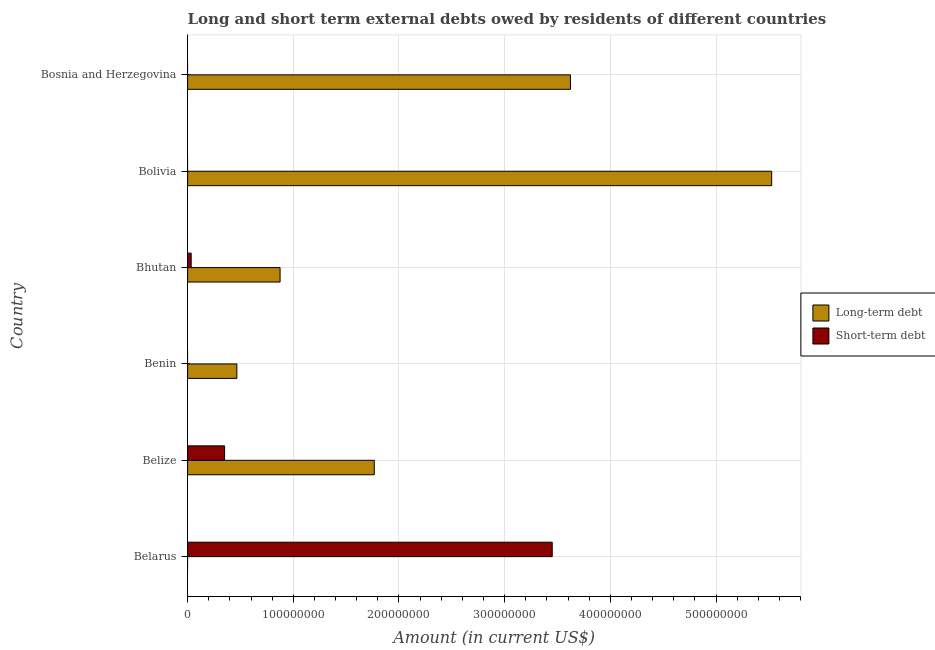How many different coloured bars are there?
Your response must be concise. 2. Are the number of bars per tick equal to the number of legend labels?
Make the answer very short. No. Are the number of bars on each tick of the Y-axis equal?
Make the answer very short. No. How many bars are there on the 3rd tick from the top?
Your answer should be very brief. 2. What is the label of the 4th group of bars from the top?
Offer a very short reply. Benin. In how many cases, is the number of bars for a given country not equal to the number of legend labels?
Offer a terse response. 4. What is the long-term debts owed by residents in Bhutan?
Keep it short and to the point. 8.75e+07. Across all countries, what is the maximum long-term debts owed by residents?
Provide a succinct answer. 5.53e+08. Across all countries, what is the minimum long-term debts owed by residents?
Provide a short and direct response. 0. What is the total short-term debts owed by residents in the graph?
Make the answer very short. 3.83e+08. What is the difference between the long-term debts owed by residents in Bolivia and that in Bosnia and Herzegovina?
Your answer should be compact. 1.90e+08. What is the difference between the short-term debts owed by residents in Bhutan and the long-term debts owed by residents in Benin?
Your answer should be very brief. -4.33e+07. What is the average short-term debts owed by residents per country?
Keep it short and to the point. 6.39e+07. What is the difference between the short-term debts owed by residents and long-term debts owed by residents in Belize?
Your response must be concise. -1.42e+08. What is the ratio of the long-term debts owed by residents in Benin to that in Bhutan?
Offer a terse response. 0.53. What is the difference between the highest and the second highest long-term debts owed by residents?
Provide a short and direct response. 1.90e+08. What is the difference between the highest and the lowest short-term debts owed by residents?
Make the answer very short. 3.45e+08. How many bars are there?
Provide a succinct answer. 8. Are all the bars in the graph horizontal?
Offer a very short reply. Yes. Does the graph contain any zero values?
Ensure brevity in your answer.  Yes. Does the graph contain grids?
Keep it short and to the point. Yes. Where does the legend appear in the graph?
Give a very brief answer. Center right. What is the title of the graph?
Provide a succinct answer. Long and short term external debts owed by residents of different countries. Does "Investments" appear as one of the legend labels in the graph?
Your answer should be very brief. No. What is the label or title of the X-axis?
Your answer should be very brief. Amount (in current US$). What is the Amount (in current US$) in Short-term debt in Belarus?
Offer a very short reply. 3.45e+08. What is the Amount (in current US$) of Long-term debt in Belize?
Ensure brevity in your answer.  1.77e+08. What is the Amount (in current US$) of Short-term debt in Belize?
Your answer should be compact. 3.50e+07. What is the Amount (in current US$) of Long-term debt in Benin?
Your answer should be compact. 4.66e+07. What is the Amount (in current US$) of Long-term debt in Bhutan?
Your response must be concise. 8.75e+07. What is the Amount (in current US$) in Short-term debt in Bhutan?
Provide a succinct answer. 3.38e+06. What is the Amount (in current US$) in Long-term debt in Bolivia?
Your response must be concise. 5.53e+08. What is the Amount (in current US$) of Long-term debt in Bosnia and Herzegovina?
Keep it short and to the point. 3.62e+08. Across all countries, what is the maximum Amount (in current US$) in Long-term debt?
Offer a terse response. 5.53e+08. Across all countries, what is the maximum Amount (in current US$) of Short-term debt?
Make the answer very short. 3.45e+08. Across all countries, what is the minimum Amount (in current US$) of Long-term debt?
Your answer should be very brief. 0. What is the total Amount (in current US$) in Long-term debt in the graph?
Make the answer very short. 1.23e+09. What is the total Amount (in current US$) of Short-term debt in the graph?
Keep it short and to the point. 3.83e+08. What is the difference between the Amount (in current US$) of Short-term debt in Belarus and that in Belize?
Offer a very short reply. 3.10e+08. What is the difference between the Amount (in current US$) in Short-term debt in Belarus and that in Bhutan?
Provide a short and direct response. 3.42e+08. What is the difference between the Amount (in current US$) in Long-term debt in Belize and that in Benin?
Keep it short and to the point. 1.30e+08. What is the difference between the Amount (in current US$) in Long-term debt in Belize and that in Bhutan?
Offer a terse response. 8.91e+07. What is the difference between the Amount (in current US$) of Short-term debt in Belize and that in Bhutan?
Provide a short and direct response. 3.16e+07. What is the difference between the Amount (in current US$) in Long-term debt in Belize and that in Bolivia?
Your answer should be compact. -3.76e+08. What is the difference between the Amount (in current US$) in Long-term debt in Belize and that in Bosnia and Herzegovina?
Provide a succinct answer. -1.86e+08. What is the difference between the Amount (in current US$) of Long-term debt in Benin and that in Bhutan?
Offer a terse response. -4.09e+07. What is the difference between the Amount (in current US$) in Long-term debt in Benin and that in Bolivia?
Your answer should be compact. -5.06e+08. What is the difference between the Amount (in current US$) in Long-term debt in Benin and that in Bosnia and Herzegovina?
Provide a succinct answer. -3.16e+08. What is the difference between the Amount (in current US$) of Long-term debt in Bhutan and that in Bolivia?
Make the answer very short. -4.65e+08. What is the difference between the Amount (in current US$) in Long-term debt in Bhutan and that in Bosnia and Herzegovina?
Your response must be concise. -2.75e+08. What is the difference between the Amount (in current US$) of Long-term debt in Bolivia and that in Bosnia and Herzegovina?
Your answer should be very brief. 1.90e+08. What is the difference between the Amount (in current US$) in Long-term debt in Belize and the Amount (in current US$) in Short-term debt in Bhutan?
Offer a very short reply. 1.73e+08. What is the difference between the Amount (in current US$) of Long-term debt in Benin and the Amount (in current US$) of Short-term debt in Bhutan?
Ensure brevity in your answer.  4.33e+07. What is the average Amount (in current US$) in Long-term debt per country?
Offer a terse response. 2.04e+08. What is the average Amount (in current US$) of Short-term debt per country?
Keep it short and to the point. 6.39e+07. What is the difference between the Amount (in current US$) in Long-term debt and Amount (in current US$) in Short-term debt in Belize?
Make the answer very short. 1.42e+08. What is the difference between the Amount (in current US$) of Long-term debt and Amount (in current US$) of Short-term debt in Bhutan?
Give a very brief answer. 8.41e+07. What is the ratio of the Amount (in current US$) in Short-term debt in Belarus to that in Belize?
Your answer should be compact. 9.86. What is the ratio of the Amount (in current US$) of Short-term debt in Belarus to that in Bhutan?
Give a very brief answer. 102.13. What is the ratio of the Amount (in current US$) of Long-term debt in Belize to that in Benin?
Give a very brief answer. 3.79. What is the ratio of the Amount (in current US$) in Long-term debt in Belize to that in Bhutan?
Make the answer very short. 2.02. What is the ratio of the Amount (in current US$) in Short-term debt in Belize to that in Bhutan?
Make the answer very short. 10.36. What is the ratio of the Amount (in current US$) of Long-term debt in Belize to that in Bolivia?
Keep it short and to the point. 0.32. What is the ratio of the Amount (in current US$) of Long-term debt in Belize to that in Bosnia and Herzegovina?
Ensure brevity in your answer.  0.49. What is the ratio of the Amount (in current US$) in Long-term debt in Benin to that in Bhutan?
Make the answer very short. 0.53. What is the ratio of the Amount (in current US$) of Long-term debt in Benin to that in Bolivia?
Offer a very short reply. 0.08. What is the ratio of the Amount (in current US$) in Long-term debt in Benin to that in Bosnia and Herzegovina?
Provide a short and direct response. 0.13. What is the ratio of the Amount (in current US$) of Long-term debt in Bhutan to that in Bolivia?
Offer a terse response. 0.16. What is the ratio of the Amount (in current US$) of Long-term debt in Bhutan to that in Bosnia and Herzegovina?
Provide a succinct answer. 0.24. What is the ratio of the Amount (in current US$) of Long-term debt in Bolivia to that in Bosnia and Herzegovina?
Your answer should be compact. 1.53. What is the difference between the highest and the second highest Amount (in current US$) of Long-term debt?
Offer a terse response. 1.90e+08. What is the difference between the highest and the second highest Amount (in current US$) in Short-term debt?
Your answer should be compact. 3.10e+08. What is the difference between the highest and the lowest Amount (in current US$) in Long-term debt?
Provide a succinct answer. 5.53e+08. What is the difference between the highest and the lowest Amount (in current US$) of Short-term debt?
Your response must be concise. 3.45e+08. 